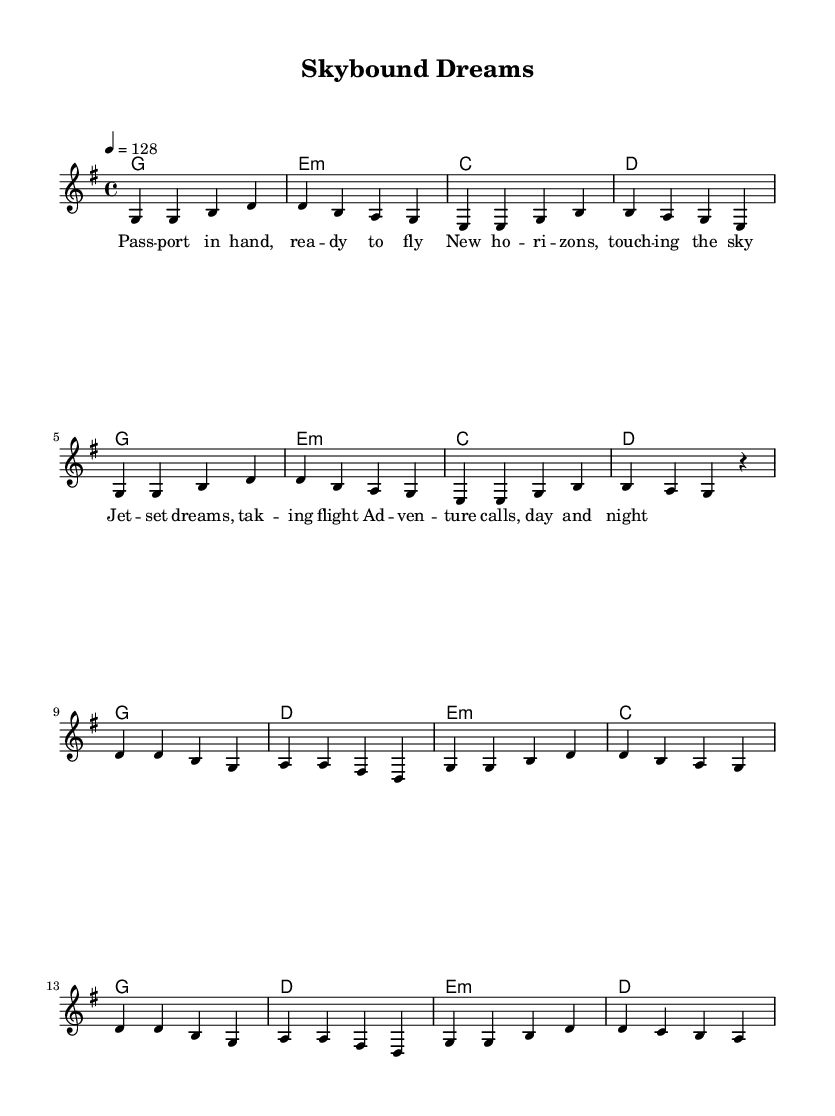What is the key signature of this music? The key signature is G major, which has one sharp. This can be identified by looking at the key signature notation at the beginning of the sheet music, which indicates the pitches that are sharped.
Answer: G major What is the time signature of this piece? The time signature is 4/4, indicated at the start of the sheet music. This means there are four beats in each measure, and each quarter note gets one beat.
Answer: 4/4 What is the tempo marking for this music? The tempo is marked as 128 beats per minute, which can be found in the tempo indication at the beginning of the score. This sets the speed at which the music should be played.
Answer: 128 How many measures are in the verse section? The verse consists of 8 measures, which can be counted from the vertical lines separating the sections in the music. Each line indicates the end of a measure.
Answer: 8 What is the highest note in the melody? The highest note in the melody is D, which appears in the first measure of the chorus section. You can identify the notes in the melody line and find the highest pitch.
Answer: D How many chords are used in the chorus? There are four different chords used in the chorus, which is determined by analyzing the chord symbols written above the melody during the chorus section. Each unique chord represents a change that accompanies the vocal line.
Answer: 4 What theme do the lyrics of the song emphasize? The lyrics emphasize adventure and travel, which can be discerned from keywords such as "jet-set dreams" and "adventure calls." Analyzing the lyrics highlights the overarching theme of exploration and excitement.
Answer: Adventure 